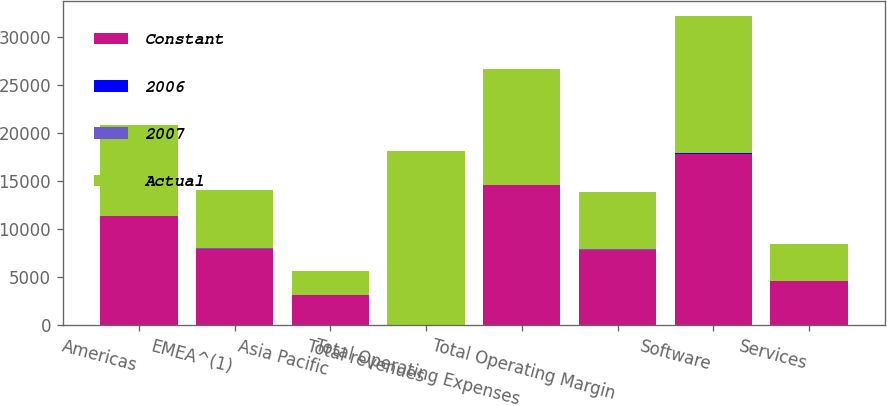Convert chart to OTSL. <chart><loc_0><loc_0><loc_500><loc_500><stacked_bar_chart><ecel><fcel>Americas<fcel>EMEA^(1)<fcel>Asia Pacific<fcel>Total revenues<fcel>Total Operating Expenses<fcel>Total Operating Margin<fcel>Software<fcel>Services<nl><fcel>Constant<fcel>11330<fcel>7945<fcel>3155<fcel>32<fcel>14586<fcel>7844<fcel>17843<fcel>4587<nl><fcel>2006<fcel>20<fcel>32<fcel>26<fcel>25<fcel>21<fcel>31<fcel>26<fcel>21<nl><fcel>2007<fcel>18<fcel>20<fcel>18<fcel>19<fcel>17<fcel>22<fcel>19<fcel>15<nl><fcel>Actual<fcel>9460<fcel>6037<fcel>2499<fcel>17996<fcel>12022<fcel>5974<fcel>14211<fcel>3785<nl></chart> 